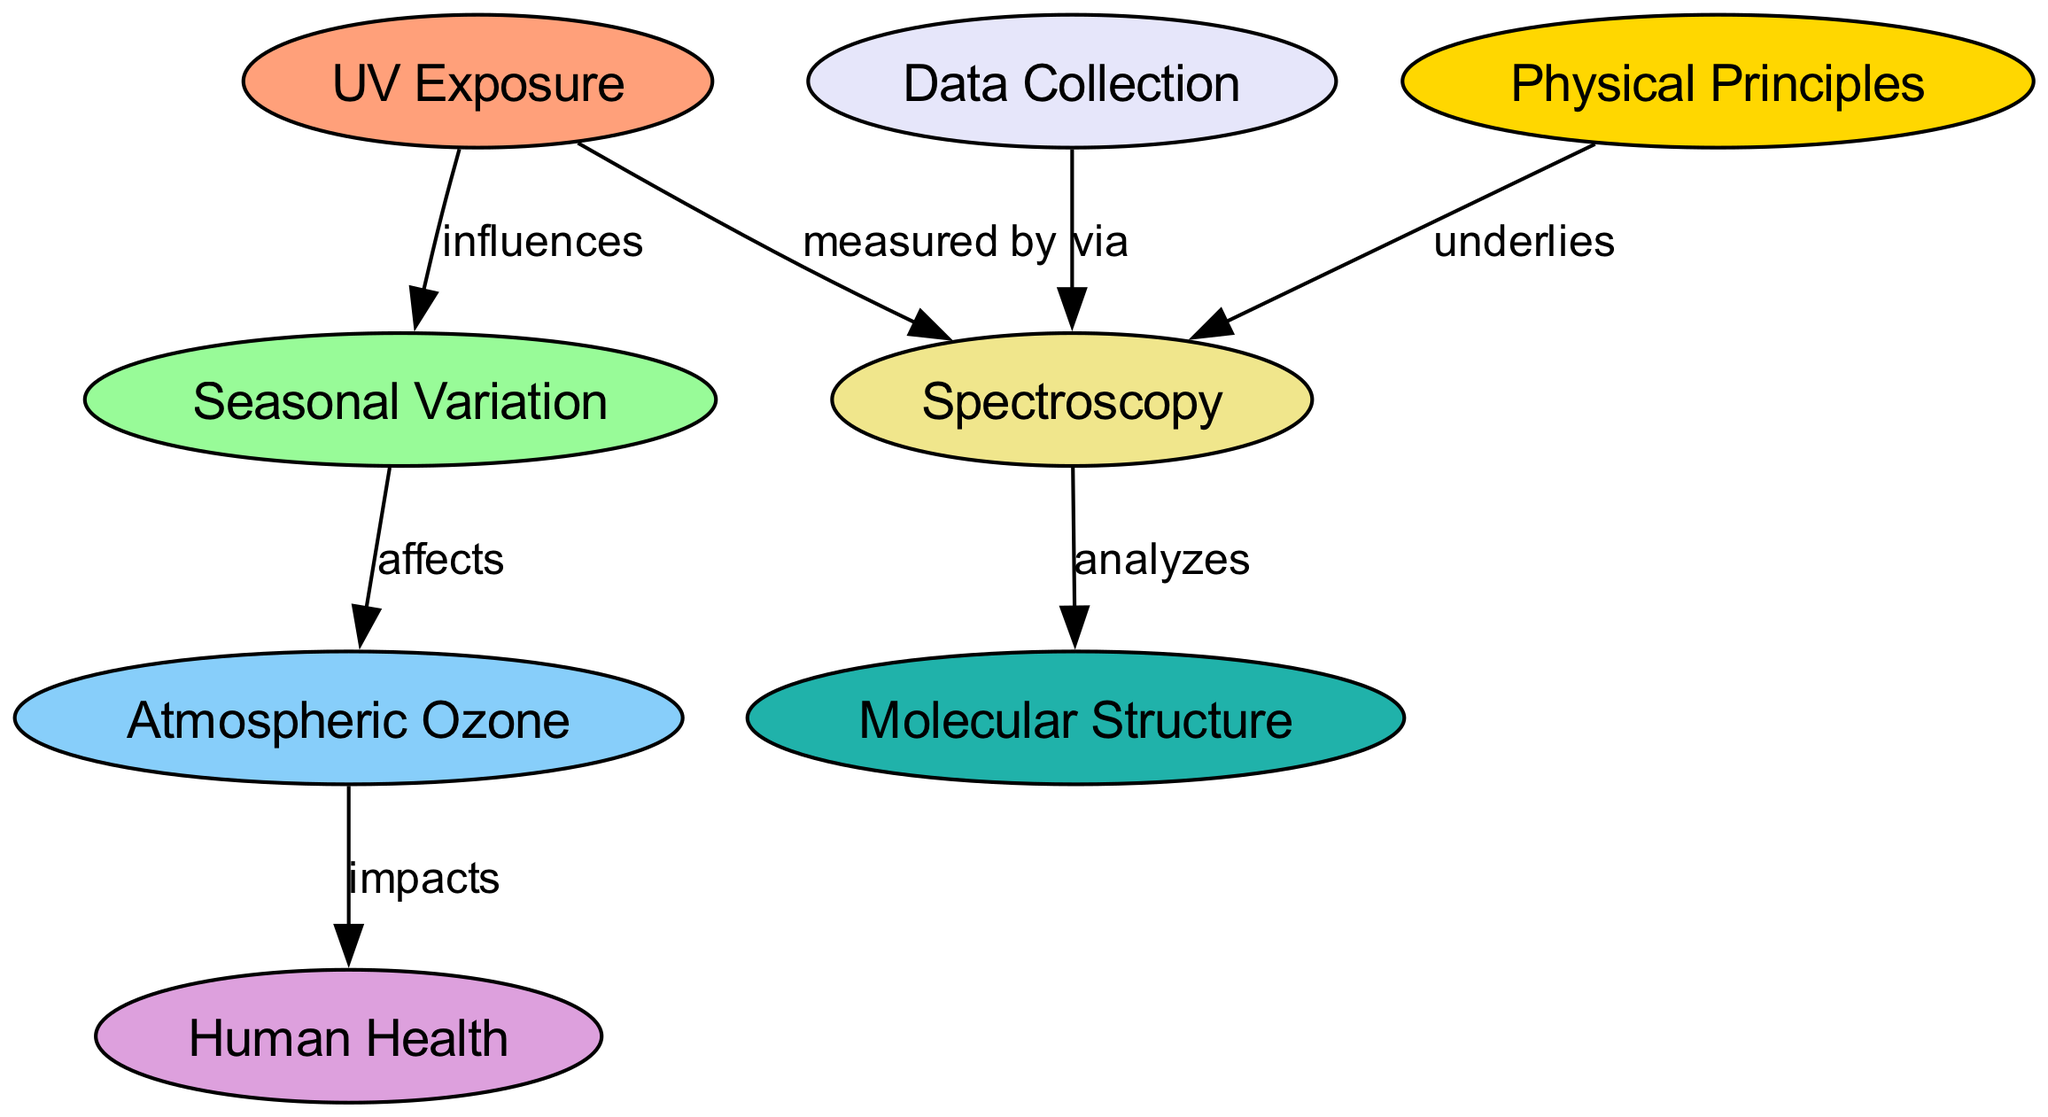What is the total number of nodes in the diagram? The diagram includes eight nodes in total: UV Exposure, Seasonal Variation, Atmospheric Ozone, Human Health, Spectroscopy, Data Collection, Physical Principles, and Molecular Structure. Counting these gives a total of eight nodes.
Answer: 8 Which node directly influences Seasonal Variation? The arrow originating from the UV Exposure node points to the Seasonal Variation node, indicating that UV Exposure directly influences Seasonal Variation.
Answer: UV Exposure How many edges are there in the diagram? The diagram has seven edges connecting the various nodes. These edges demonstrate the relationships between the nodes. Counting each connection provides the total of seven edges.
Answer: 7 What does Atmospheric Ozone impact? The arrow pointing from the Atmospheric Ozone node to the Human Health node indicates that Atmospheric Ozone impacts Human Health. The flow shows the connection between these two nodes.
Answer: Human Health What method is used to measure UV Exposure? The connection between the UV Exposure node and the Spectroscopy node shows that UV Exposure is measured by Spectroscopy, indicating the method used in this context.
Answer: Spectroscopy Which node is affected by Seasonal Variation? The Seasonal Variation node has a direct connection that leads to the Atmospheric Ozone node, meaning that Atmospheric Ozone is the node affected by Seasonal Variation.
Answer: Atmospheric Ozone Which two nodes are linked through the concept of Physical Principles? There is an edge that connects the Physical Principles node to the Spectroscopy node, signifying that Physical Principles underlie Spectroscopy, showing a foundational relationship between these concepts.
Answer: Spectroscopy How does Data Collection relate to Spectroscopy? The diagram shows that data is collected via Spectroscopy, indicating a process where data collection is achieved through the use of Spectroscopy. This links both nodes in a methodological manner.
Answer: via Spectroscopy 